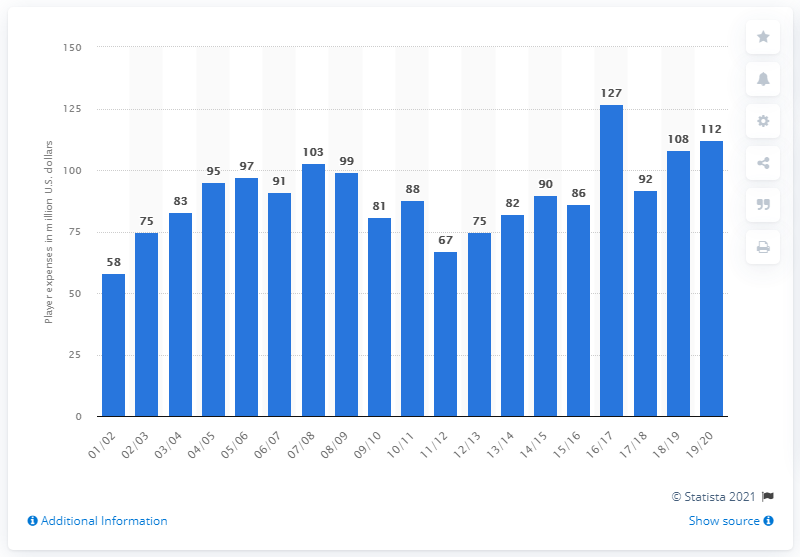Highlight a few significant elements in this photo. The Dallas Mavericks earned a salary of 112 in the 2019/20 season. 